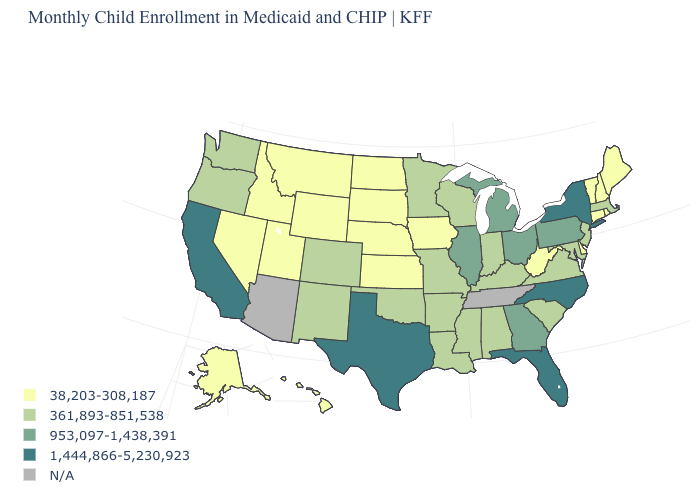What is the value of Ohio?
Quick response, please. 953,097-1,438,391. What is the value of Hawaii?
Give a very brief answer. 38,203-308,187. What is the value of New Hampshire?
Concise answer only. 38,203-308,187. Which states hav the highest value in the Northeast?
Keep it brief. New York. What is the value of New York?
Answer briefly. 1,444,866-5,230,923. Name the states that have a value in the range 361,893-851,538?
Quick response, please. Alabama, Arkansas, Colorado, Indiana, Kentucky, Louisiana, Maryland, Massachusetts, Minnesota, Mississippi, Missouri, New Jersey, New Mexico, Oklahoma, Oregon, South Carolina, Virginia, Washington, Wisconsin. What is the value of Hawaii?
Keep it brief. 38,203-308,187. What is the highest value in the South ?
Answer briefly. 1,444,866-5,230,923. Name the states that have a value in the range 361,893-851,538?
Quick response, please. Alabama, Arkansas, Colorado, Indiana, Kentucky, Louisiana, Maryland, Massachusetts, Minnesota, Mississippi, Missouri, New Jersey, New Mexico, Oklahoma, Oregon, South Carolina, Virginia, Washington, Wisconsin. What is the value of Georgia?
Write a very short answer. 953,097-1,438,391. Among the states that border Missouri , which have the highest value?
Be succinct. Illinois. Does the map have missing data?
Quick response, please. Yes. 